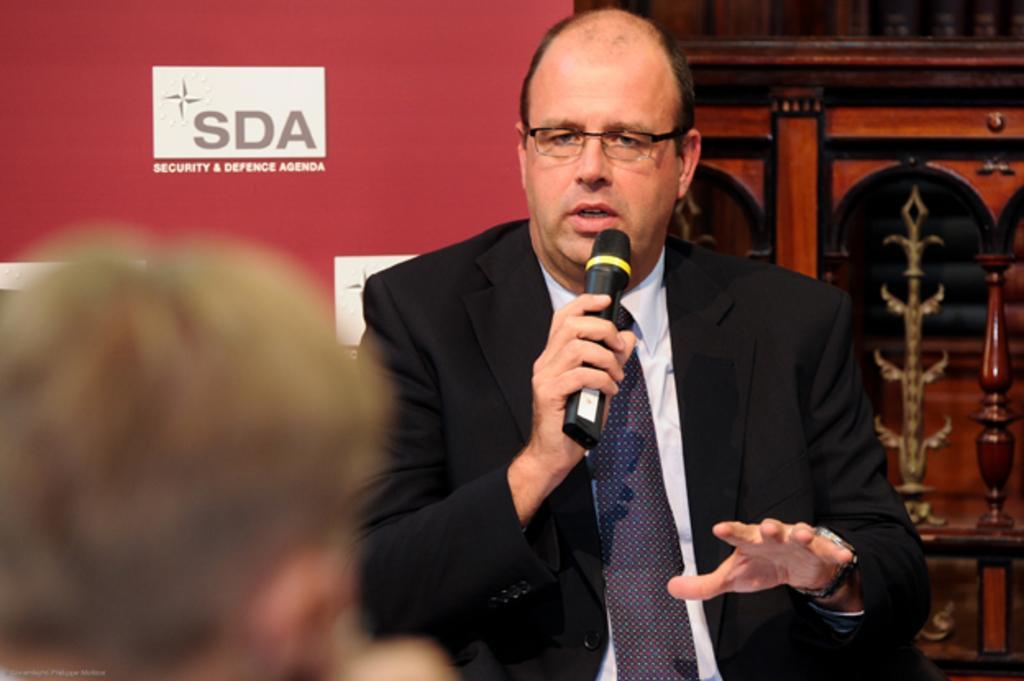How would you summarize this image in a sentence or two? In this picture there is a man standing holding a microphone in his hand and speaking. 